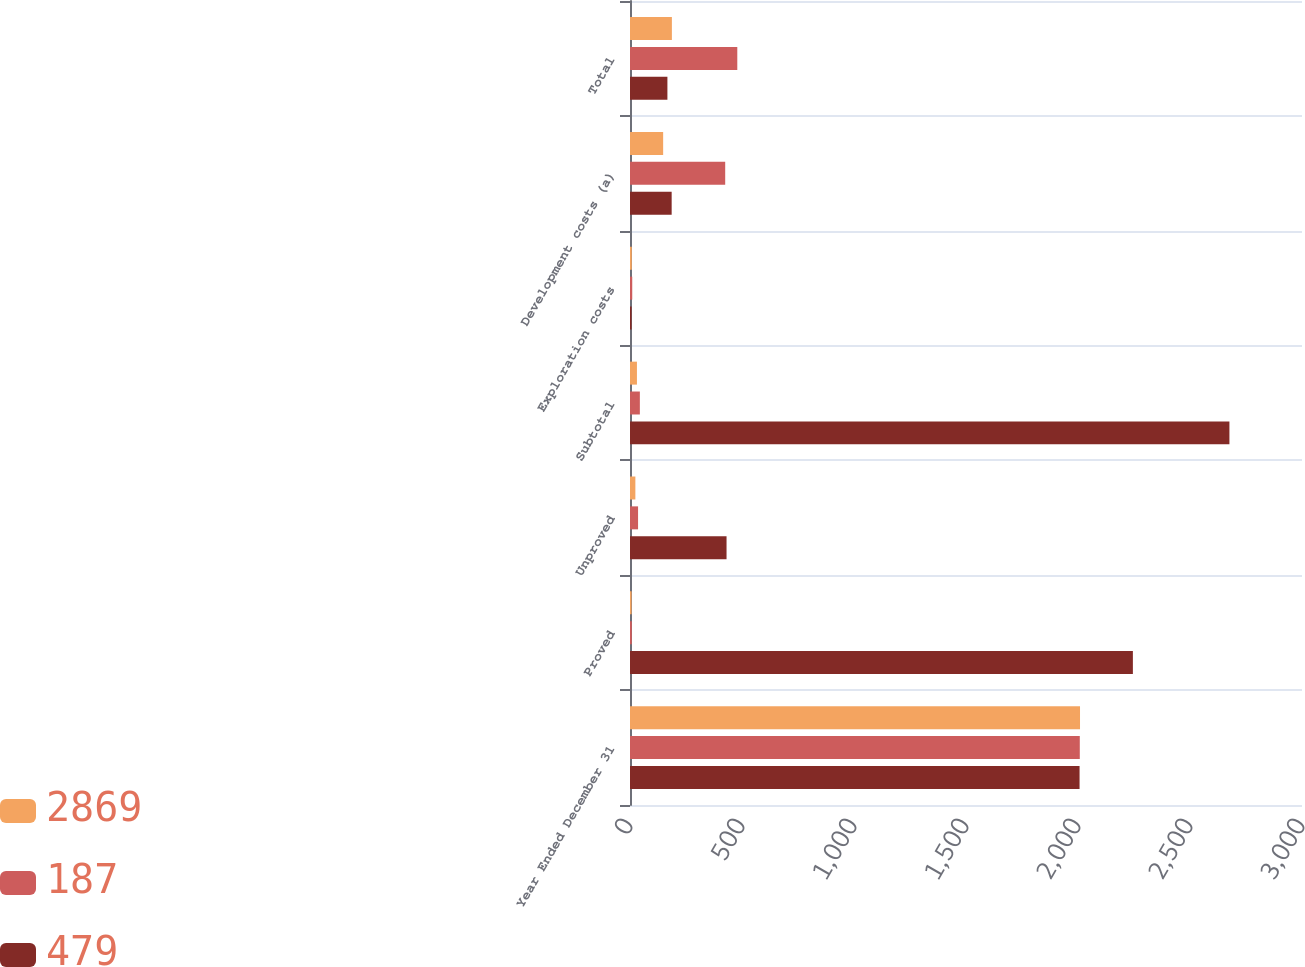<chart> <loc_0><loc_0><loc_500><loc_500><stacked_bar_chart><ecel><fcel>Year Ended December 31<fcel>Proved<fcel>Unproved<fcel>Subtotal<fcel>Exploration costs<fcel>Development costs (a)<fcel>Total<nl><fcel>2869<fcel>2009<fcel>7<fcel>24<fcel>31<fcel>8<fcel>148<fcel>187<nl><fcel>187<fcel>2008<fcel>8<fcel>36<fcel>44<fcel>10<fcel>425<fcel>479<nl><fcel>479<fcel>2007<fcel>2245<fcel>431<fcel>2676<fcel>7<fcel>186<fcel>167<nl></chart> 